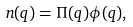<formula> <loc_0><loc_0><loc_500><loc_500>n ( q ) = \Pi ( q ) \phi ( q ) ,</formula> 